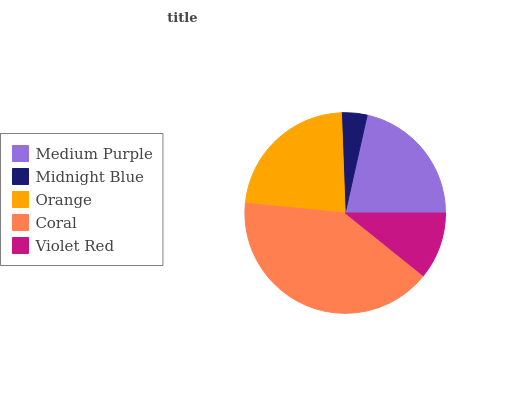Is Midnight Blue the minimum?
Answer yes or no. Yes. Is Coral the maximum?
Answer yes or no. Yes. Is Orange the minimum?
Answer yes or no. No. Is Orange the maximum?
Answer yes or no. No. Is Orange greater than Midnight Blue?
Answer yes or no. Yes. Is Midnight Blue less than Orange?
Answer yes or no. Yes. Is Midnight Blue greater than Orange?
Answer yes or no. No. Is Orange less than Midnight Blue?
Answer yes or no. No. Is Medium Purple the high median?
Answer yes or no. Yes. Is Medium Purple the low median?
Answer yes or no. Yes. Is Orange the high median?
Answer yes or no. No. Is Coral the low median?
Answer yes or no. No. 